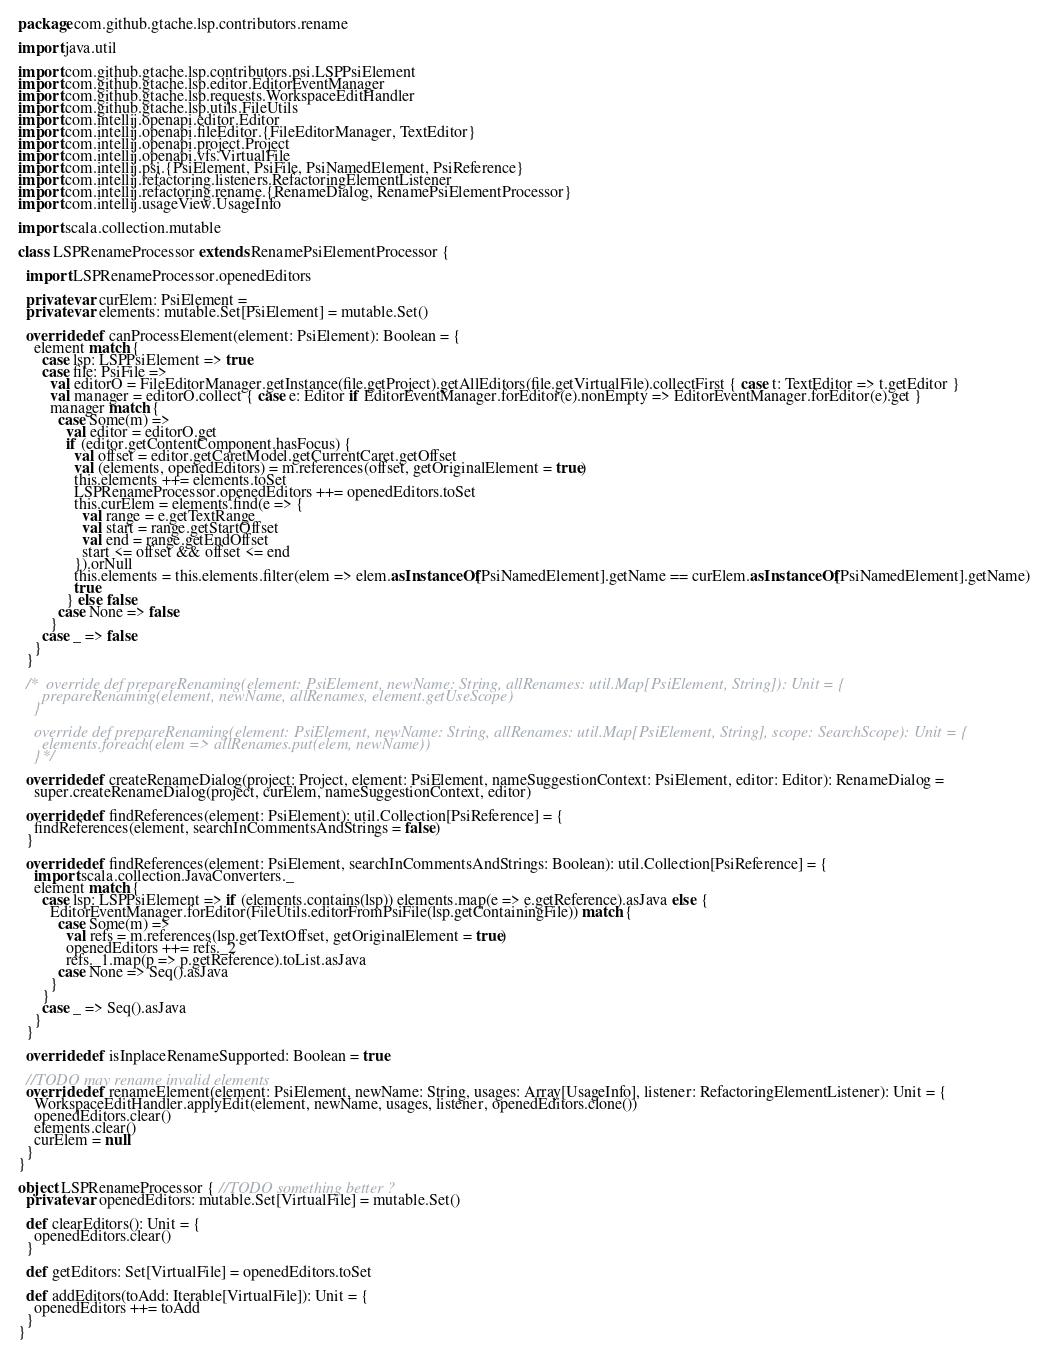Convert code to text. <code><loc_0><loc_0><loc_500><loc_500><_Scala_>package com.github.gtache.lsp.contributors.rename

import java.util

import com.github.gtache.lsp.contributors.psi.LSPPsiElement
import com.github.gtache.lsp.editor.EditorEventManager
import com.github.gtache.lsp.requests.WorkspaceEditHandler
import com.github.gtache.lsp.utils.FileUtils
import com.intellij.openapi.editor.Editor
import com.intellij.openapi.fileEditor.{FileEditorManager, TextEditor}
import com.intellij.openapi.project.Project
import com.intellij.openapi.vfs.VirtualFile
import com.intellij.psi.{PsiElement, PsiFile, PsiNamedElement, PsiReference}
import com.intellij.refactoring.listeners.RefactoringElementListener
import com.intellij.refactoring.rename.{RenameDialog, RenamePsiElementProcessor}
import com.intellij.usageView.UsageInfo

import scala.collection.mutable

class LSPRenameProcessor extends RenamePsiElementProcessor {

  import LSPRenameProcessor.openedEditors

  private var curElem: PsiElement = _
  private var elements: mutable.Set[PsiElement] = mutable.Set()

  override def canProcessElement(element: PsiElement): Boolean = {
    element match {
      case lsp: LSPPsiElement => true
      case file: PsiFile =>
        val editorO = FileEditorManager.getInstance(file.getProject).getAllEditors(file.getVirtualFile).collectFirst { case t: TextEditor => t.getEditor }
        val manager = editorO.collect { case e: Editor if EditorEventManager.forEditor(e).nonEmpty => EditorEventManager.forEditor(e).get }
        manager match {
          case Some(m) =>
            val editor = editorO.get
            if (editor.getContentComponent.hasFocus) {
              val offset = editor.getCaretModel.getCurrentCaret.getOffset
              val (elements, openedEditors) = m.references(offset, getOriginalElement = true)
              this.elements ++= elements.toSet
              LSPRenameProcessor.openedEditors ++= openedEditors.toSet
              this.curElem = elements.find(e => {
                val range = e.getTextRange
                val start = range.getStartOffset
                val end = range.getEndOffset
                start <= offset && offset <= end
              }).orNull
              this.elements = this.elements.filter(elem => elem.asInstanceOf[PsiNamedElement].getName == curElem.asInstanceOf[PsiNamedElement].getName)
              true
            } else false
          case None => false
        }
      case _ => false
    }
  }

  /*  override def prepareRenaming(element: PsiElement, newName: String, allRenames: util.Map[PsiElement, String]): Unit = {
      prepareRenaming(element, newName, allRenames, element.getUseScope)
    }

    override def prepareRenaming(element: PsiElement, newName: String, allRenames: util.Map[PsiElement, String], scope: SearchScope): Unit = {
      elements.foreach(elem => allRenames.put(elem, newName))
    }*/

  override def createRenameDialog(project: Project, element: PsiElement, nameSuggestionContext: PsiElement, editor: Editor): RenameDialog =
    super.createRenameDialog(project, curElem, nameSuggestionContext, editor)

  override def findReferences(element: PsiElement): util.Collection[PsiReference] = {
    findReferences(element, searchInCommentsAndStrings = false)
  }

  override def findReferences(element: PsiElement, searchInCommentsAndStrings: Boolean): util.Collection[PsiReference] = {
    import scala.collection.JavaConverters._
    element match {
      case lsp: LSPPsiElement => if (elements.contains(lsp)) elements.map(e => e.getReference).asJava else {
        EditorEventManager.forEditor(FileUtils.editorFromPsiFile(lsp.getContainingFile)) match {
          case Some(m) =>
            val refs = m.references(lsp.getTextOffset, getOriginalElement = true)
            openedEditors ++= refs._2
            refs._1.map(p => p.getReference).toList.asJava
          case None => Seq().asJava
        }
      }
      case _ => Seq().asJava
    }
  }

  override def isInplaceRenameSupported: Boolean = true

  //TODO may rename invalid elements
  override def renameElement(element: PsiElement, newName: String, usages: Array[UsageInfo], listener: RefactoringElementListener): Unit = {
    WorkspaceEditHandler.applyEdit(element, newName, usages, listener, openedEditors.clone())
    openedEditors.clear()
    elements.clear()
    curElem = null
  }
}

object LSPRenameProcessor { //TODO something better ?
  private var openedEditors: mutable.Set[VirtualFile] = mutable.Set()

  def clearEditors(): Unit = {
    openedEditors.clear()
  }

  def getEditors: Set[VirtualFile] = openedEditors.toSet

  def addEditors(toAdd: Iterable[VirtualFile]): Unit = {
    openedEditors ++= toAdd
  }
}</code> 